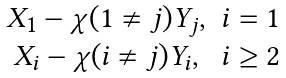<formula> <loc_0><loc_0><loc_500><loc_500>\begin{matrix} X _ { 1 } - \chi ( 1 \ne j ) { Y _ { j } } , & i = 1 \\ X _ { i } - \chi ( i \ne j ) { Y _ { i } } , & i \geq 2 \end{matrix}</formula> 